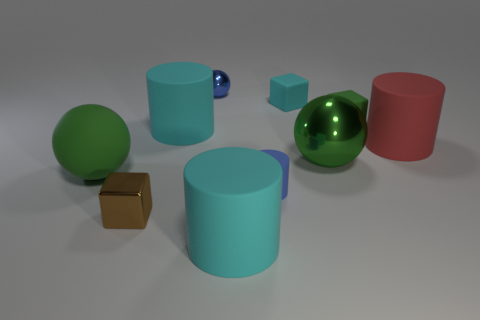What size is the thing that is behind the large metal sphere and on the left side of the tiny ball? The object behind the large metal sphere and to the left of the small ball appears to be a large blue cylinder, roughly twice the height of the adjacent green sphere. The cylinder's size and simplistic shape contrast with the smaller, more reflective tiny ball beside it. 